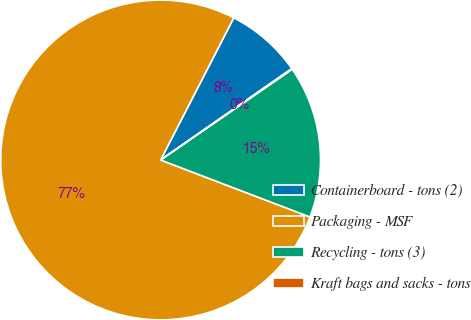<chart> <loc_0><loc_0><loc_500><loc_500><pie_chart><fcel>Containerboard - tons (2)<fcel>Packaging - MSF<fcel>Recycling - tons (3)<fcel>Kraft bags and sacks - tons<nl><fcel>7.75%<fcel>76.76%<fcel>15.41%<fcel>0.08%<nl></chart> 